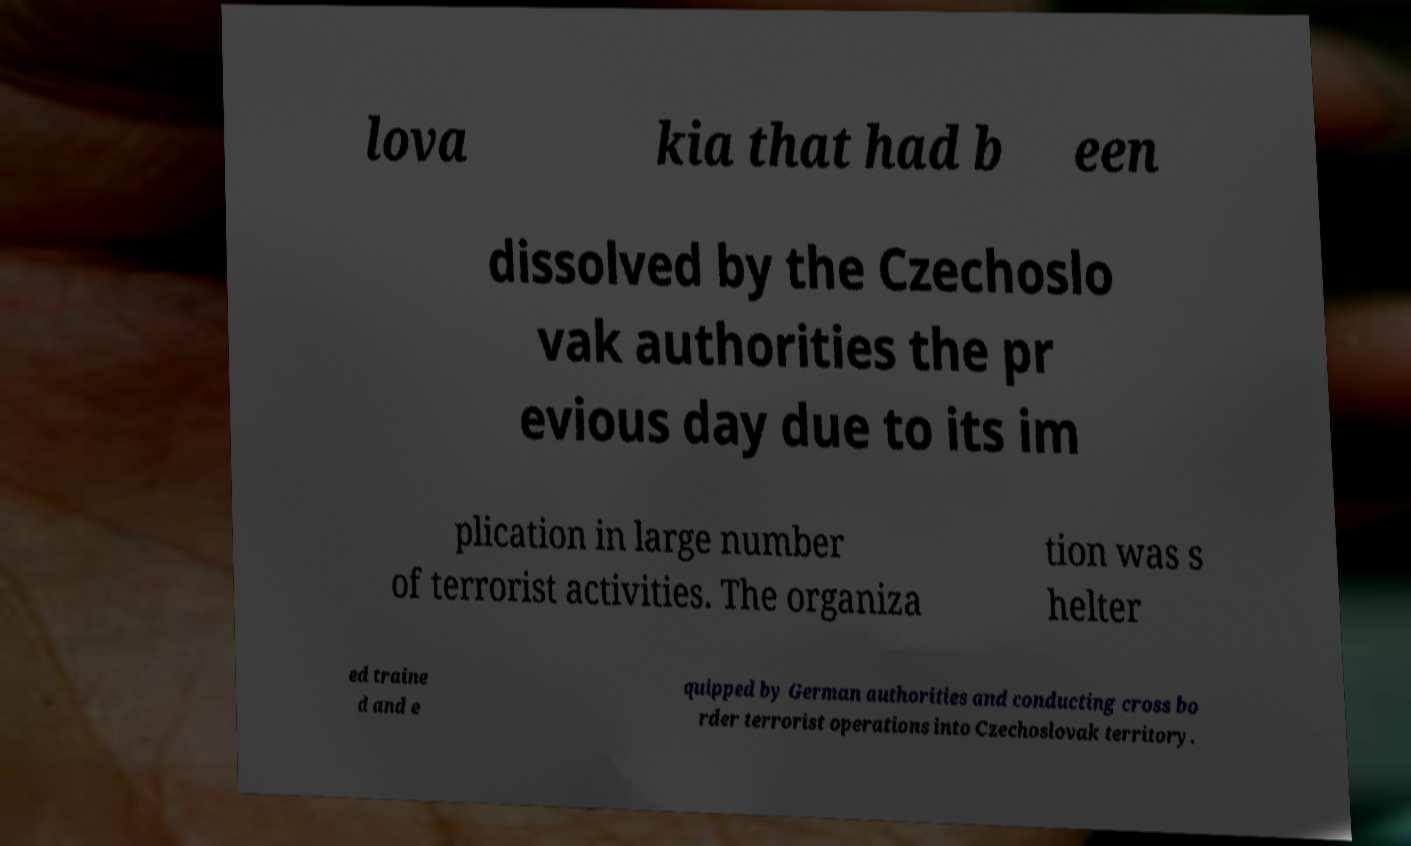What messages or text are displayed in this image? I need them in a readable, typed format. lova kia that had b een dissolved by the Czechoslo vak authorities the pr evious day due to its im plication in large number of terrorist activities. The organiza tion was s helter ed traine d and e quipped by German authorities and conducting cross bo rder terrorist operations into Czechoslovak territory. 